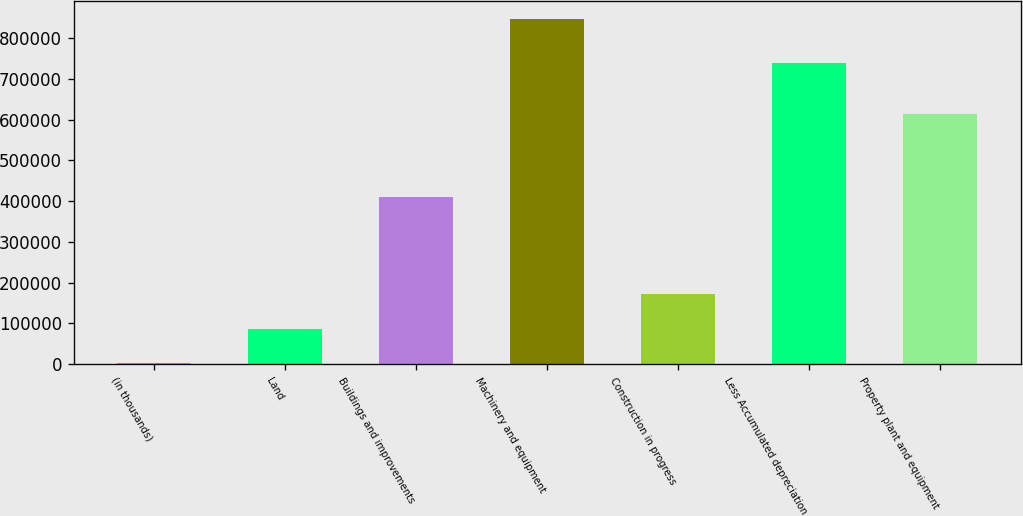Convert chart. <chart><loc_0><loc_0><loc_500><loc_500><bar_chart><fcel>(in thousands)<fcel>Land<fcel>Buildings and improvements<fcel>Machinery and equipment<fcel>Construction in progress<fcel>Less Accumulated depreciation<fcel>Property plant and equipment<nl><fcel>2012<fcel>86643.9<fcel>409451<fcel>848331<fcel>171276<fcel>739285<fcel>614705<nl></chart> 